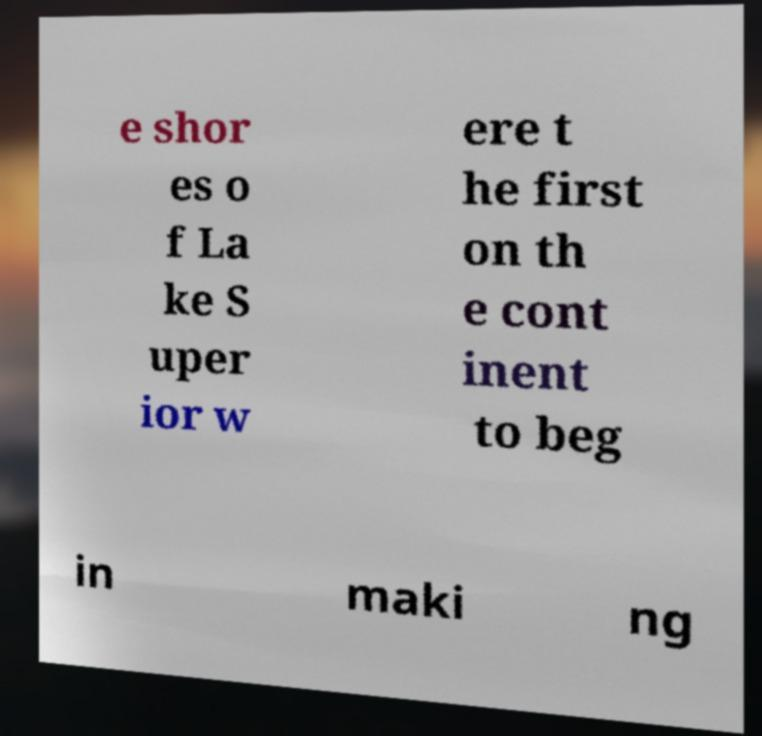Please read and relay the text visible in this image. What does it say? e shor es o f La ke S uper ior w ere t he first on th e cont inent to beg in maki ng 